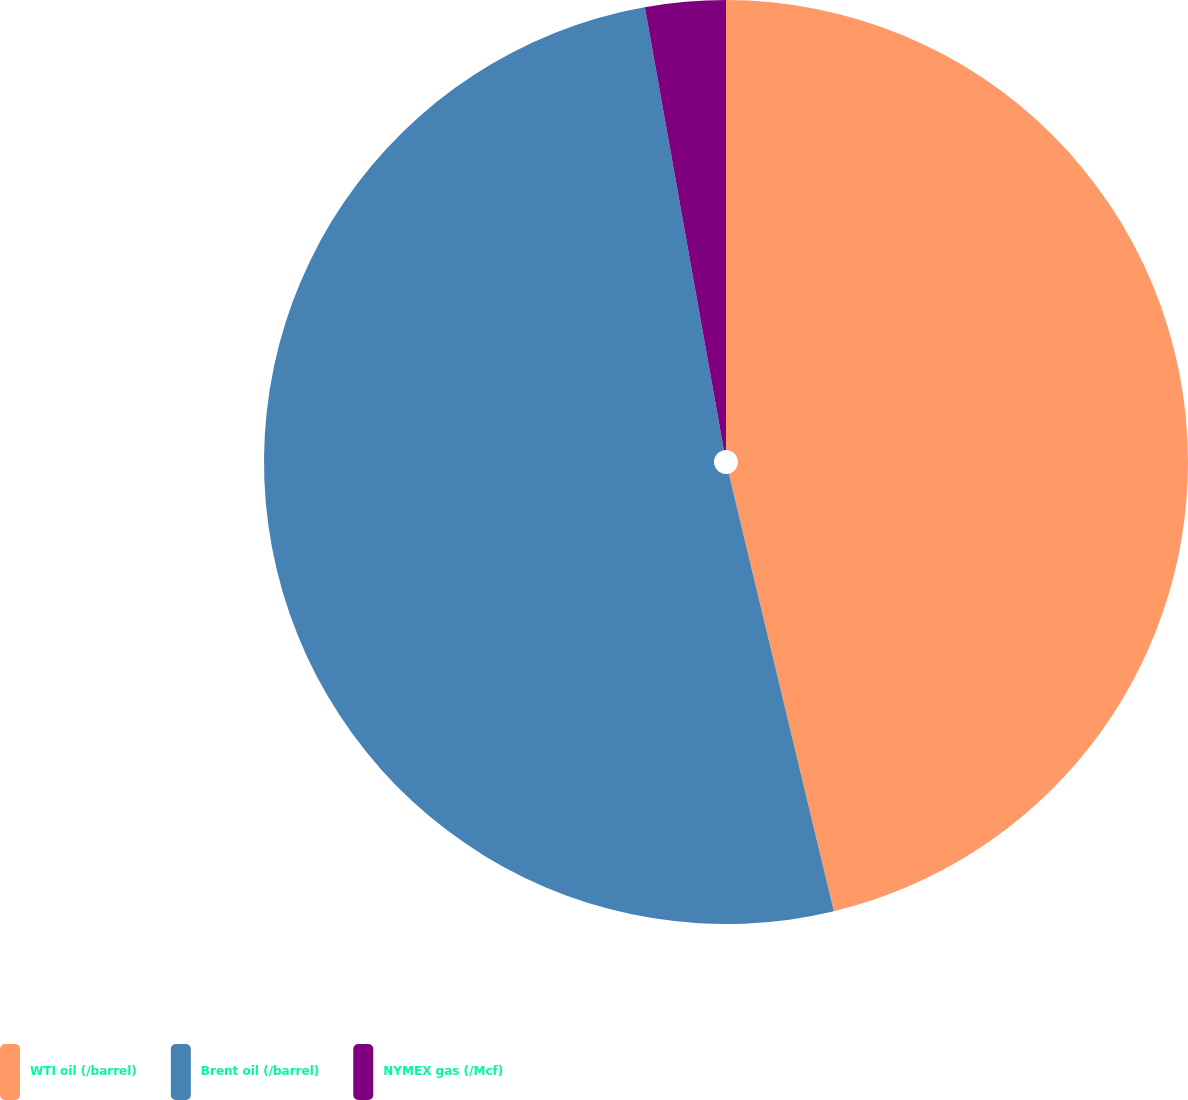<chart> <loc_0><loc_0><loc_500><loc_500><pie_chart><fcel>WTI oil (/barrel)<fcel>Brent oil (/barrel)<fcel>NYMEX gas (/Mcf)<nl><fcel>46.25%<fcel>50.94%<fcel>2.81%<nl></chart> 